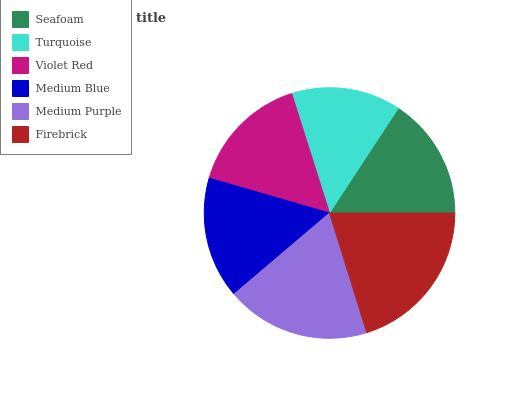Is Turquoise the minimum?
Answer yes or no. Yes. Is Firebrick the maximum?
Answer yes or no. Yes. Is Violet Red the minimum?
Answer yes or no. No. Is Violet Red the maximum?
Answer yes or no. No. Is Violet Red greater than Turquoise?
Answer yes or no. Yes. Is Turquoise less than Violet Red?
Answer yes or no. Yes. Is Turquoise greater than Violet Red?
Answer yes or no. No. Is Violet Red less than Turquoise?
Answer yes or no. No. Is Seafoam the high median?
Answer yes or no. Yes. Is Medium Blue the low median?
Answer yes or no. Yes. Is Medium Purple the high median?
Answer yes or no. No. Is Turquoise the low median?
Answer yes or no. No. 